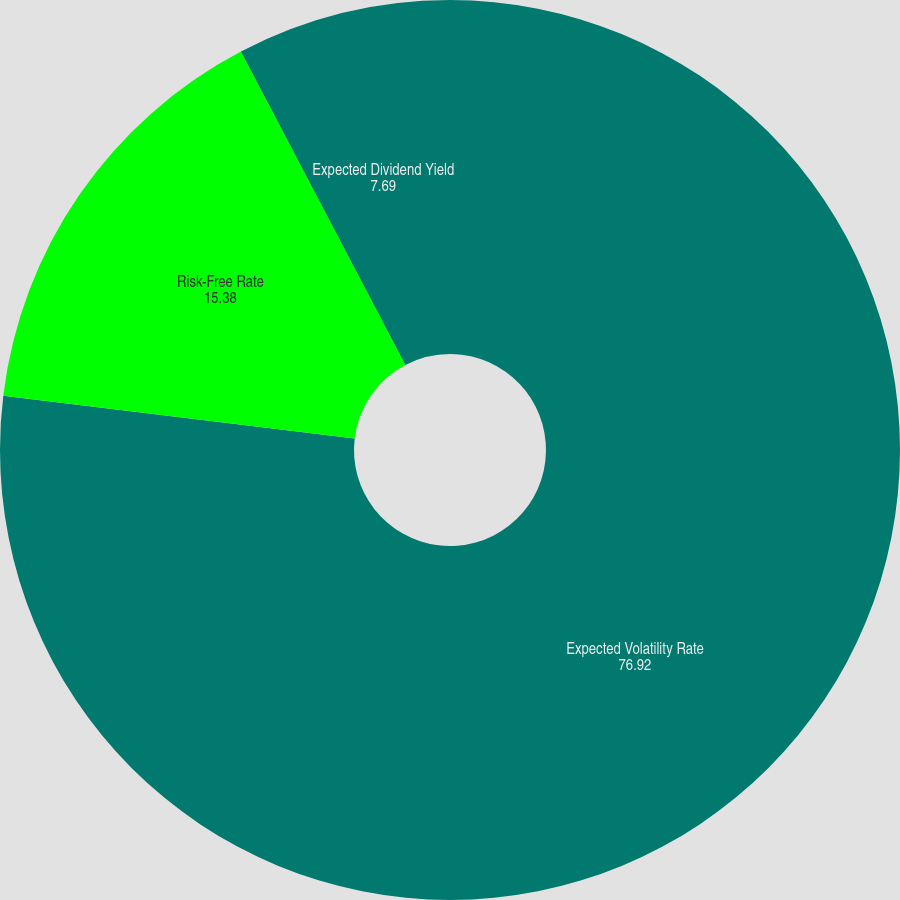Convert chart to OTSL. <chart><loc_0><loc_0><loc_500><loc_500><pie_chart><fcel>Expected Volatility Rate<fcel>Risk-Free Rate<fcel>Expected Dividend Yield<nl><fcel>76.92%<fcel>15.38%<fcel>7.69%<nl></chart> 